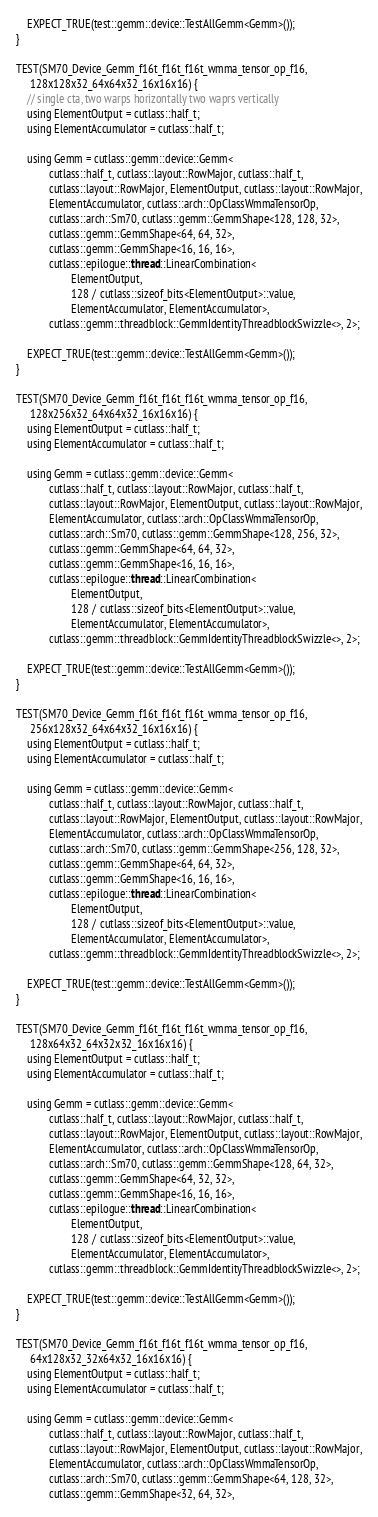Convert code to text. <code><loc_0><loc_0><loc_500><loc_500><_Cuda_>    EXPECT_TRUE(test::gemm::device::TestAllGemm<Gemm>());
}

TEST(SM70_Device_Gemm_f16t_f16t_f16t_wmma_tensor_op_f16,
     128x128x32_64x64x32_16x16x16) {
    // single cta, two warps horizontally two waprs vertically
    using ElementOutput = cutlass::half_t;
    using ElementAccumulator = cutlass::half_t;

    using Gemm = cutlass::gemm::device::Gemm<
            cutlass::half_t, cutlass::layout::RowMajor, cutlass::half_t,
            cutlass::layout::RowMajor, ElementOutput, cutlass::layout::RowMajor,
            ElementAccumulator, cutlass::arch::OpClassWmmaTensorOp,
            cutlass::arch::Sm70, cutlass::gemm::GemmShape<128, 128, 32>,
            cutlass::gemm::GemmShape<64, 64, 32>,
            cutlass::gemm::GemmShape<16, 16, 16>,
            cutlass::epilogue::thread::LinearCombination<
                    ElementOutput,
                    128 / cutlass::sizeof_bits<ElementOutput>::value,
                    ElementAccumulator, ElementAccumulator>,
            cutlass::gemm::threadblock::GemmIdentityThreadblockSwizzle<>, 2>;

    EXPECT_TRUE(test::gemm::device::TestAllGemm<Gemm>());
}

TEST(SM70_Device_Gemm_f16t_f16t_f16t_wmma_tensor_op_f16,
     128x256x32_64x64x32_16x16x16) {
    using ElementOutput = cutlass::half_t;
    using ElementAccumulator = cutlass::half_t;

    using Gemm = cutlass::gemm::device::Gemm<
            cutlass::half_t, cutlass::layout::RowMajor, cutlass::half_t,
            cutlass::layout::RowMajor, ElementOutput, cutlass::layout::RowMajor,
            ElementAccumulator, cutlass::arch::OpClassWmmaTensorOp,
            cutlass::arch::Sm70, cutlass::gemm::GemmShape<128, 256, 32>,
            cutlass::gemm::GemmShape<64, 64, 32>,
            cutlass::gemm::GemmShape<16, 16, 16>,
            cutlass::epilogue::thread::LinearCombination<
                    ElementOutput,
                    128 / cutlass::sizeof_bits<ElementOutput>::value,
                    ElementAccumulator, ElementAccumulator>,
            cutlass::gemm::threadblock::GemmIdentityThreadblockSwizzle<>, 2>;

    EXPECT_TRUE(test::gemm::device::TestAllGemm<Gemm>());
}

TEST(SM70_Device_Gemm_f16t_f16t_f16t_wmma_tensor_op_f16,
     256x128x32_64x64x32_16x16x16) {
    using ElementOutput = cutlass::half_t;
    using ElementAccumulator = cutlass::half_t;

    using Gemm = cutlass::gemm::device::Gemm<
            cutlass::half_t, cutlass::layout::RowMajor, cutlass::half_t,
            cutlass::layout::RowMajor, ElementOutput, cutlass::layout::RowMajor,
            ElementAccumulator, cutlass::arch::OpClassWmmaTensorOp,
            cutlass::arch::Sm70, cutlass::gemm::GemmShape<256, 128, 32>,
            cutlass::gemm::GemmShape<64, 64, 32>,
            cutlass::gemm::GemmShape<16, 16, 16>,
            cutlass::epilogue::thread::LinearCombination<
                    ElementOutput,
                    128 / cutlass::sizeof_bits<ElementOutput>::value,
                    ElementAccumulator, ElementAccumulator>,
            cutlass::gemm::threadblock::GemmIdentityThreadblockSwizzle<>, 2>;

    EXPECT_TRUE(test::gemm::device::TestAllGemm<Gemm>());
}

TEST(SM70_Device_Gemm_f16t_f16t_f16t_wmma_tensor_op_f16,
     128x64x32_64x32x32_16x16x16) {
    using ElementOutput = cutlass::half_t;
    using ElementAccumulator = cutlass::half_t;

    using Gemm = cutlass::gemm::device::Gemm<
            cutlass::half_t, cutlass::layout::RowMajor, cutlass::half_t,
            cutlass::layout::RowMajor, ElementOutput, cutlass::layout::RowMajor,
            ElementAccumulator, cutlass::arch::OpClassWmmaTensorOp,
            cutlass::arch::Sm70, cutlass::gemm::GemmShape<128, 64, 32>,
            cutlass::gemm::GemmShape<64, 32, 32>,
            cutlass::gemm::GemmShape<16, 16, 16>,
            cutlass::epilogue::thread::LinearCombination<
                    ElementOutput,
                    128 / cutlass::sizeof_bits<ElementOutput>::value,
                    ElementAccumulator, ElementAccumulator>,
            cutlass::gemm::threadblock::GemmIdentityThreadblockSwizzle<>, 2>;

    EXPECT_TRUE(test::gemm::device::TestAllGemm<Gemm>());
}

TEST(SM70_Device_Gemm_f16t_f16t_f16t_wmma_tensor_op_f16,
     64x128x32_32x64x32_16x16x16) {
    using ElementOutput = cutlass::half_t;
    using ElementAccumulator = cutlass::half_t;

    using Gemm = cutlass::gemm::device::Gemm<
            cutlass::half_t, cutlass::layout::RowMajor, cutlass::half_t,
            cutlass::layout::RowMajor, ElementOutput, cutlass::layout::RowMajor,
            ElementAccumulator, cutlass::arch::OpClassWmmaTensorOp,
            cutlass::arch::Sm70, cutlass::gemm::GemmShape<64, 128, 32>,
            cutlass::gemm::GemmShape<32, 64, 32>,</code> 